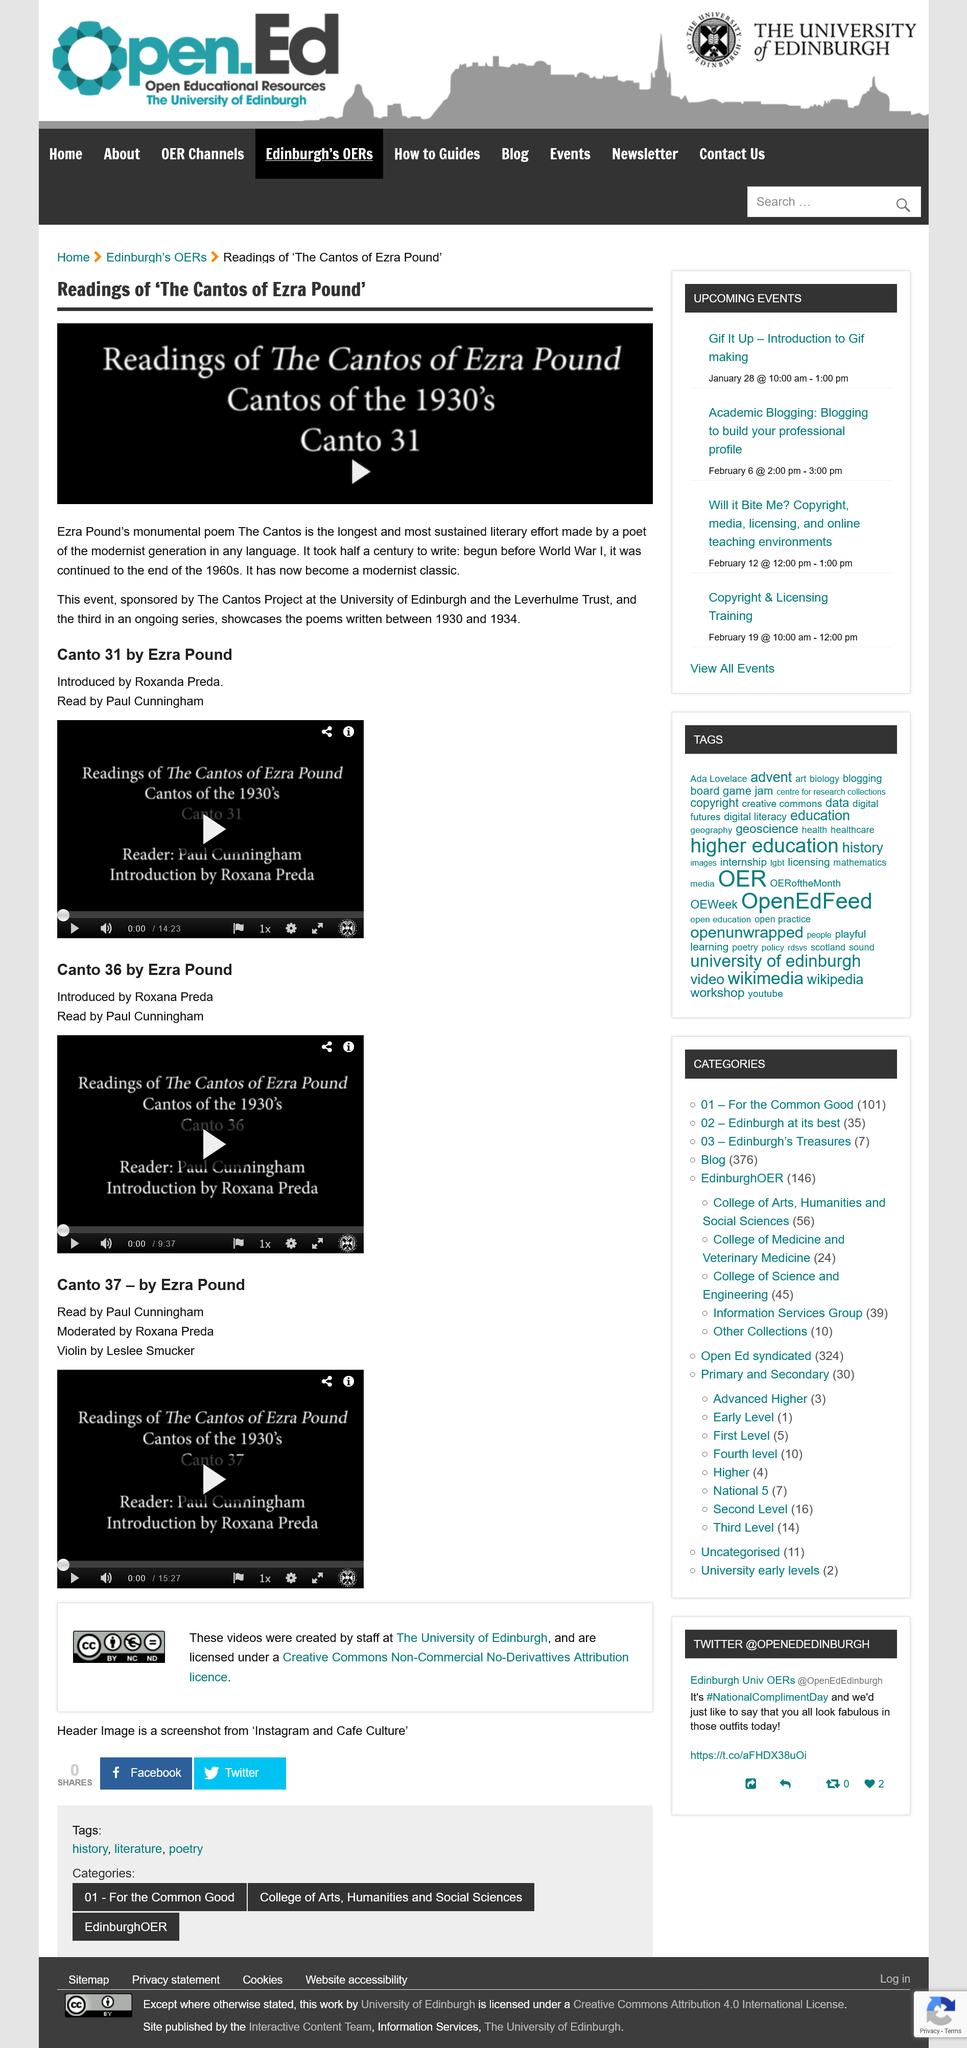Mention a couple of crucial points in this snapshot. The Cantos inspired an event called "Readings of the Cantos of Ezra Pound," which is sponsored by The Cantos Project and the Leverhulme Trust. The Cantos Project is based at the University of Edinburgh. Ezra Pound wrote the poem The Cantos. 